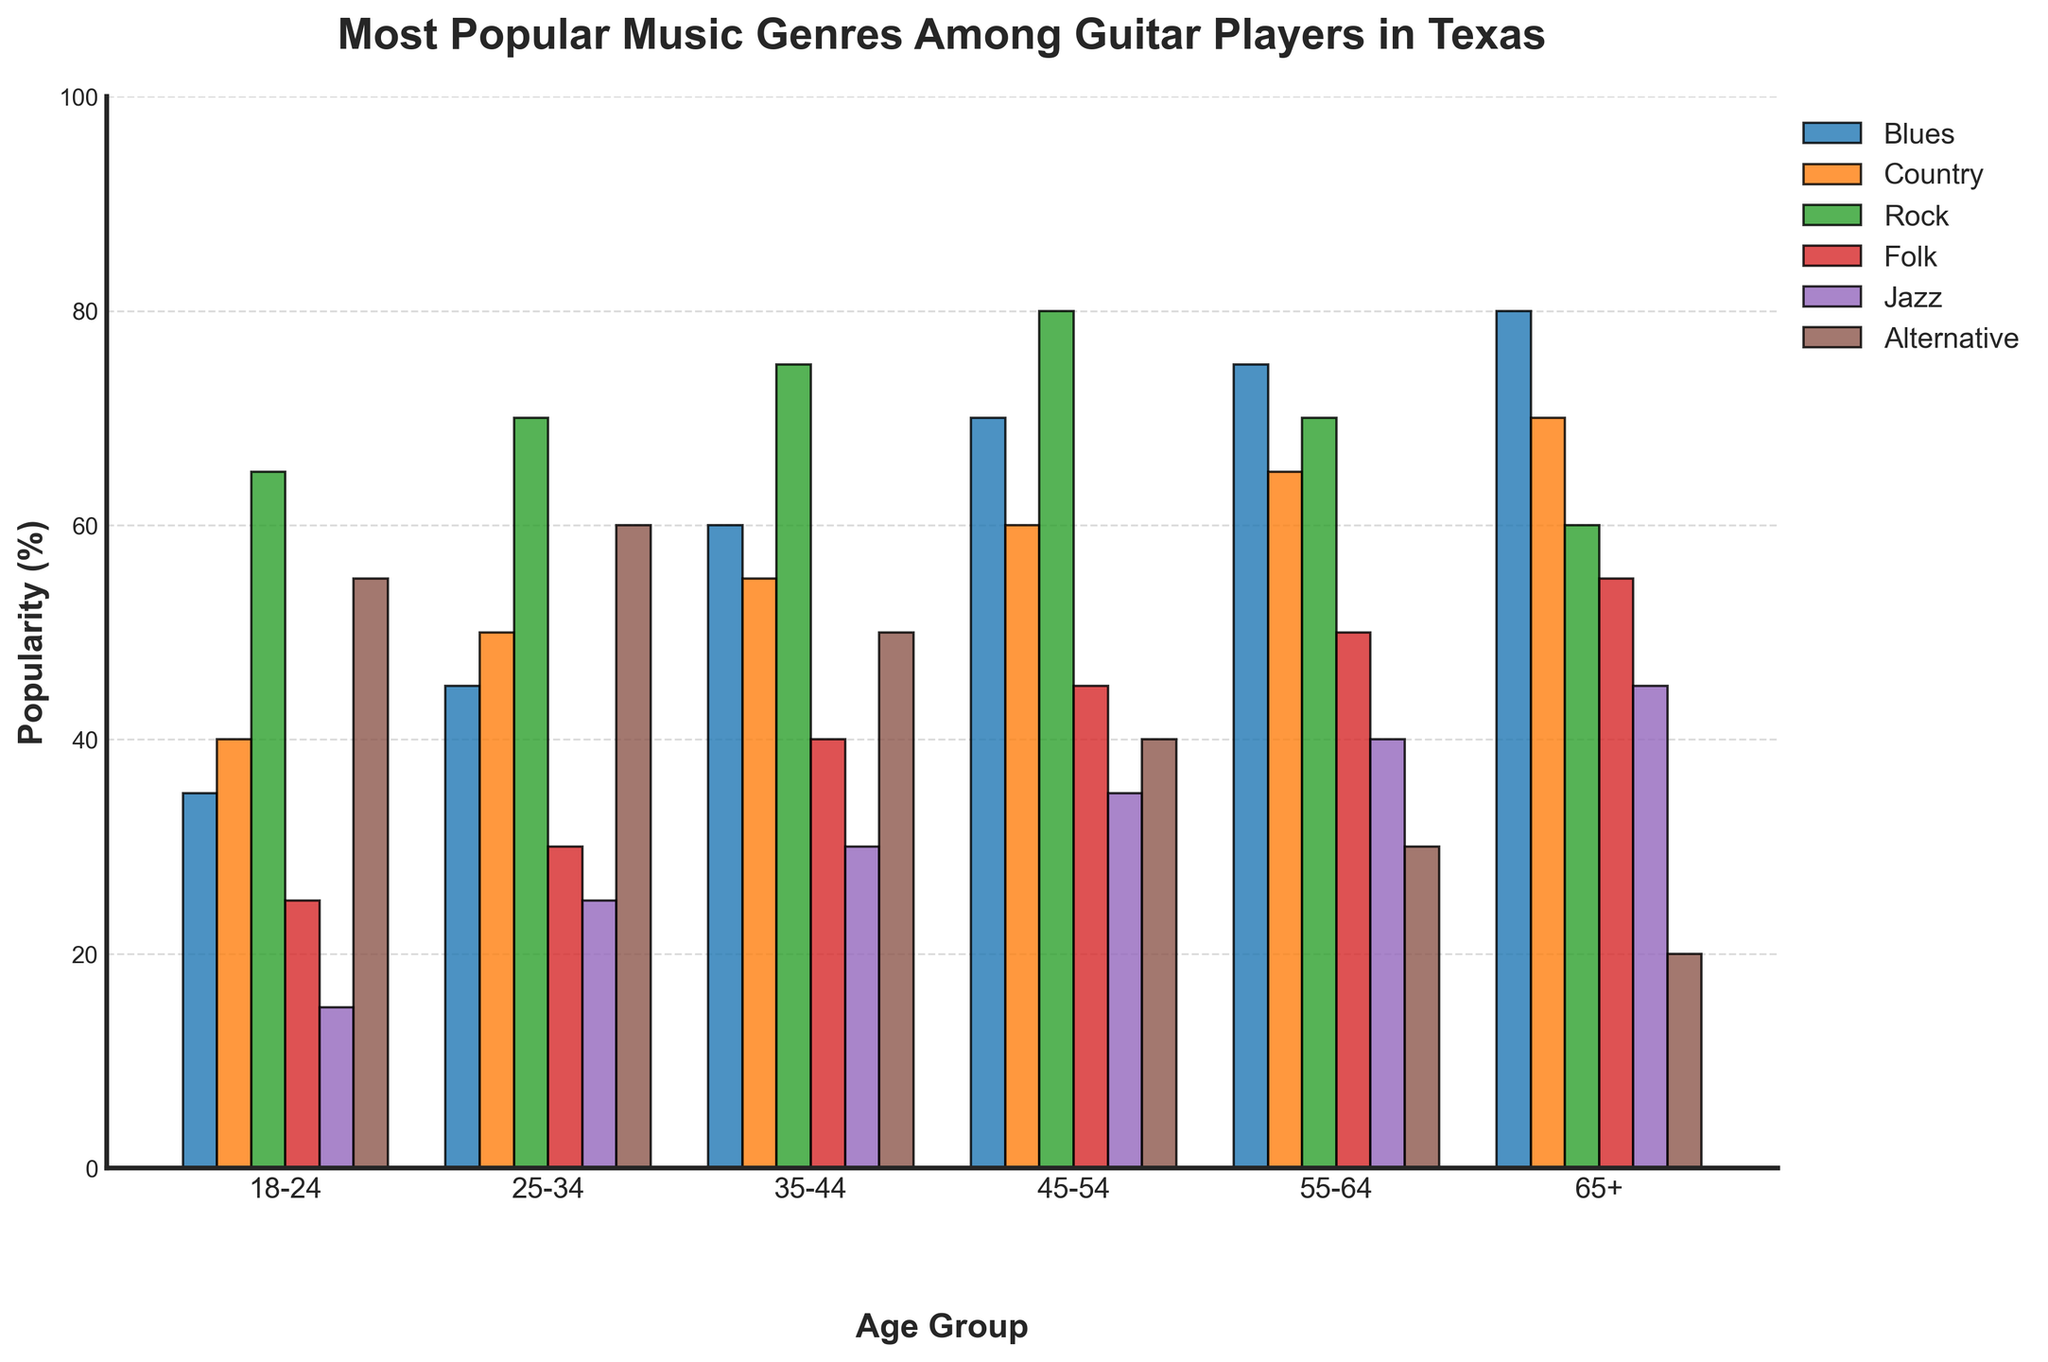What's the most popular music genre among guitar players aged 45-54? Look at the bar with the highest height for the age group 45-54. The highest bar is for the Rock genre.
Answer: Rock Which age group has the highest popularity percentage for the Jazz genre? Find the highest bar in the Jazz category and note its corresponding age group. The highest bar in the Jazz category is for the 65+ age group.
Answer: 65+ What is the difference in popularity percentage between Country and Alternative genres for the 25-34 age group? Look at the bars for Country and Alternative genres in the 25-34 age group and calculate the difference: 60 (Alternative) - 50 (Country) = 10.
Answer: 10 Which age group shows the lowest popularity for the Folk genre? Identify the shortest bar in the Folk category and note its corresponding age group. The shortest bar in the Folk category is for the 18-24 age group.
Answer: 18-24 What is the average popularity percentage of Blues and Country genres among the 55-64 age group? Add the values of Blues and Country genres for the 55-64 age group and divide by 2: (75+65)/2 = 70.
Answer: 70 Which genre shows a consistent increase in popularity across all age groups? Compare the height of the bars for all age groups for each genre. The Blues genre consistently increases in popularity across all age groups.
Answer: Blues Which genre has the least popularity among guitar players aged 65+? Identify the shortest bar for the age group 65+ and note the genre. The shortest bar for the age group 65+ is the Alternative genre.
Answer: Alternative What is the sum of popularity percentages for the Rock genre across all age groups? Add the values for the Rock genre across all age groups: 65+70+75+80+70+60 = 420.
Answer: 420 Which age group has the highest overall popularity percentage across all genres? Calculate the sum of all genres for each age group and compare. The 45-54 age group has the highest overall popularity percentage: 70+60+80+45+35+40=330.
Answer: 45-54 